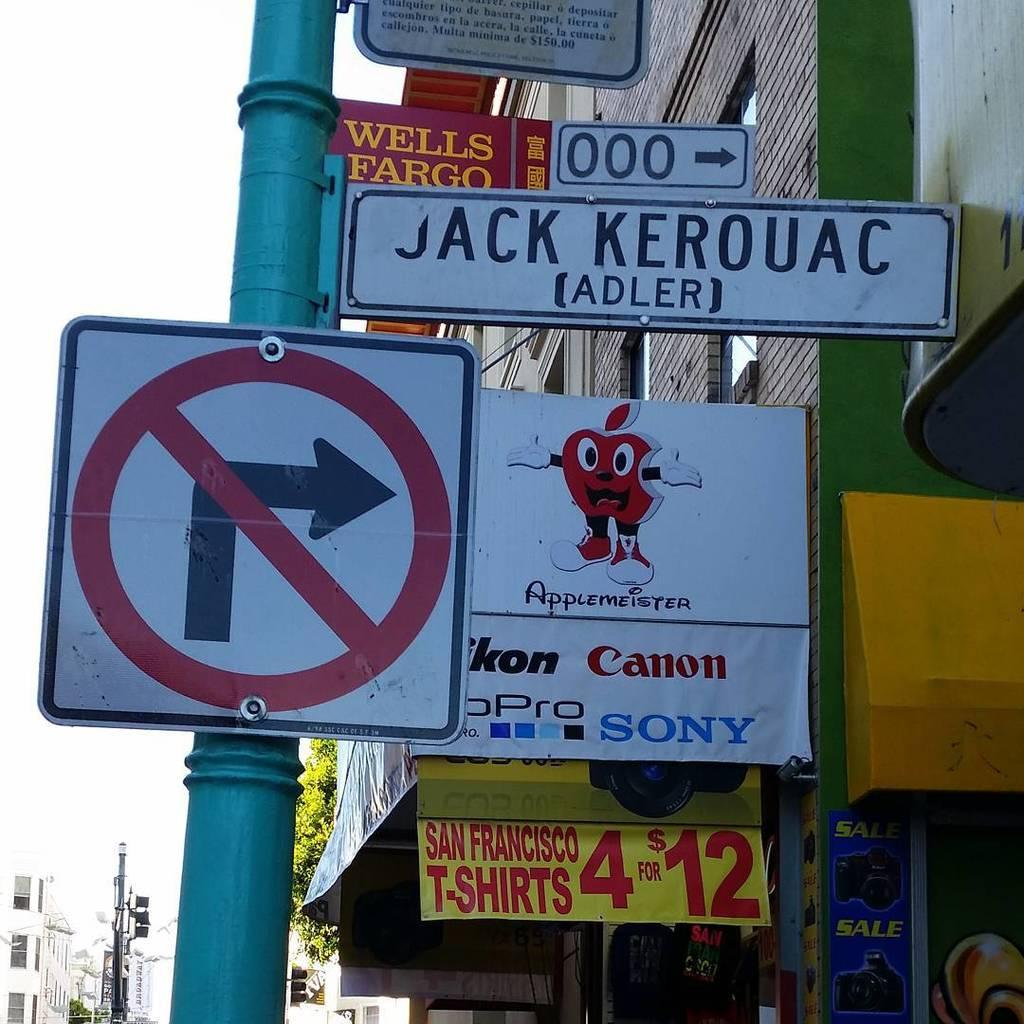<image>
Present a compact description of the photo's key features. The name of the bank institution above the apple logo is Wells Fargo. 